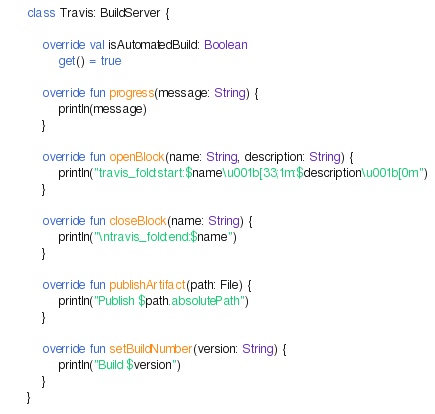<code> <loc_0><loc_0><loc_500><loc_500><_Kotlin_>
class Travis: BuildServer {

    override val isAutomatedBuild: Boolean
        get() = true

    override fun progress(message: String) {
        println(message)
    }

    override fun openBlock(name: String, description: String) {
        println("travis_fold:start:$name\u001b[33;1m:$description\u001b[0m")
    }

    override fun closeBlock(name: String) {
        println("\ntravis_fold:end:$name")
    }

    override fun publishArtifact(path: File) {
        println("Publish $path.absolutePath")
    }

    override fun setBuildNumber(version: String) {
        println("Build $version")
    }
}</code> 